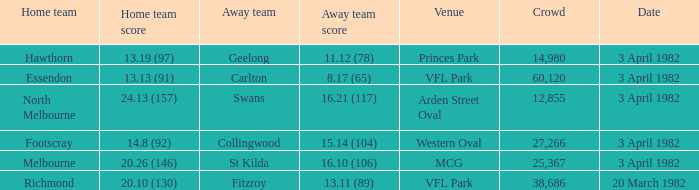When the away team scored 11.12 (78), what was the date of the game? 3 April 1982. 